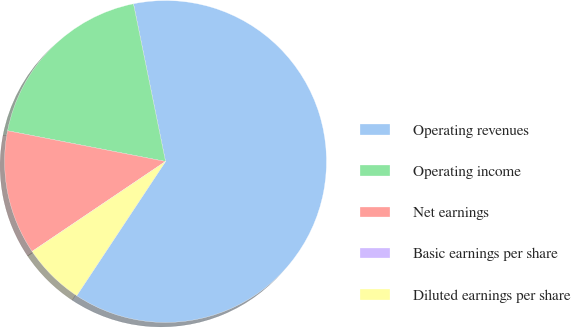Convert chart. <chart><loc_0><loc_0><loc_500><loc_500><pie_chart><fcel>Operating revenues<fcel>Operating income<fcel>Net earnings<fcel>Basic earnings per share<fcel>Diluted earnings per share<nl><fcel>62.5%<fcel>18.75%<fcel>12.5%<fcel>0.0%<fcel>6.25%<nl></chart> 